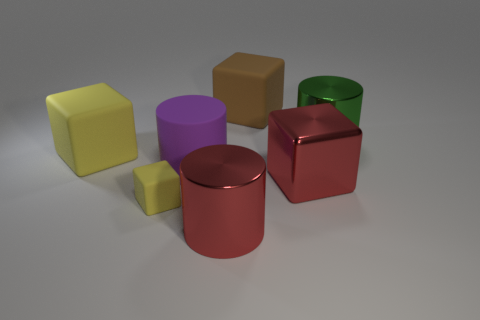Is there a big gray cylinder made of the same material as the brown cube?
Provide a short and direct response. No. What is the shape of the rubber object that is in front of the red shiny thing that is behind the matte object in front of the large red metallic cube?
Your answer should be compact. Cube. There is a large block on the right side of the brown cube; is it the same color as the big cylinder behind the big yellow matte thing?
Ensure brevity in your answer.  No. Is there any other thing that is the same size as the brown matte object?
Keep it short and to the point. Yes. Are there any large red metal blocks in front of the large red metallic cylinder?
Keep it short and to the point. No. What number of red metallic objects have the same shape as the large yellow thing?
Your response must be concise. 1. What is the color of the large metallic object on the right side of the large red object that is right of the big cylinder that is in front of the big shiny block?
Provide a succinct answer. Green. Is the material of the cylinder in front of the purple object the same as the big green thing that is behind the purple cylinder?
Make the answer very short. Yes. How many things are either rubber things that are in front of the green cylinder or rubber objects?
Give a very brief answer. 4. How many objects are either blue rubber spheres or metal cylinders that are in front of the big yellow rubber cube?
Offer a terse response. 1. 